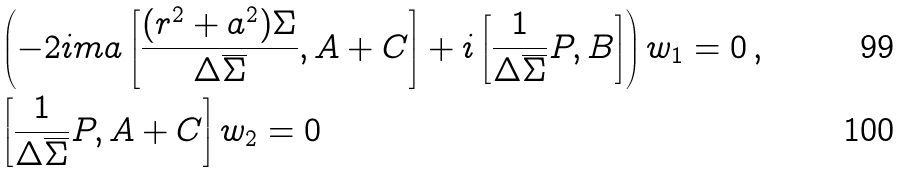<formula> <loc_0><loc_0><loc_500><loc_500>& \left ( - 2 i m a \left [ \frac { ( r ^ { 2 } + a ^ { 2 } ) \Sigma } { \Delta \overline { \Sigma } } , A + C \right ] + i \left [ \frac { 1 } { \Delta \overline { \Sigma } } P , B \right ] \right ) w _ { 1 } = 0 \, , \\ & \left [ \frac { 1 } { \Delta \overline { \Sigma } } P , A + C \right ] w _ { 2 } = 0</formula> 